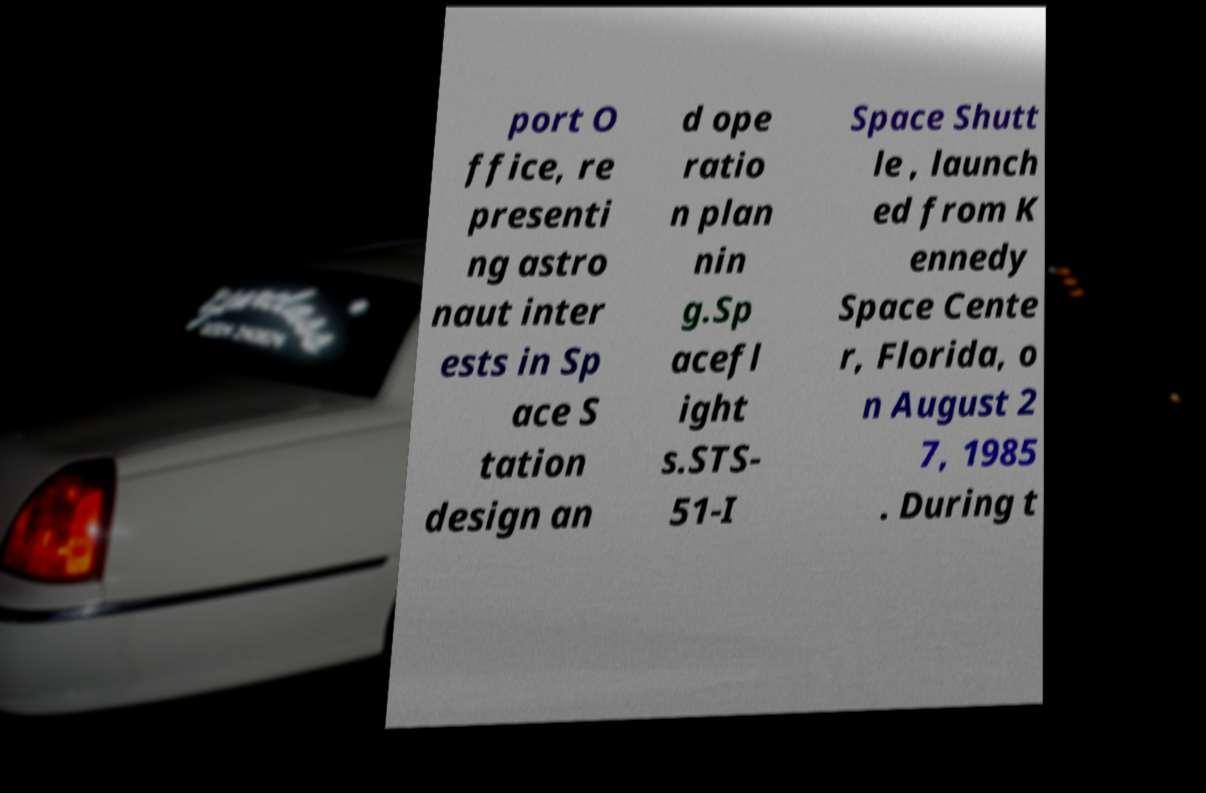For documentation purposes, I need the text within this image transcribed. Could you provide that? port O ffice, re presenti ng astro naut inter ests in Sp ace S tation design an d ope ratio n plan nin g.Sp acefl ight s.STS- 51-I Space Shutt le , launch ed from K ennedy Space Cente r, Florida, o n August 2 7, 1985 . During t 